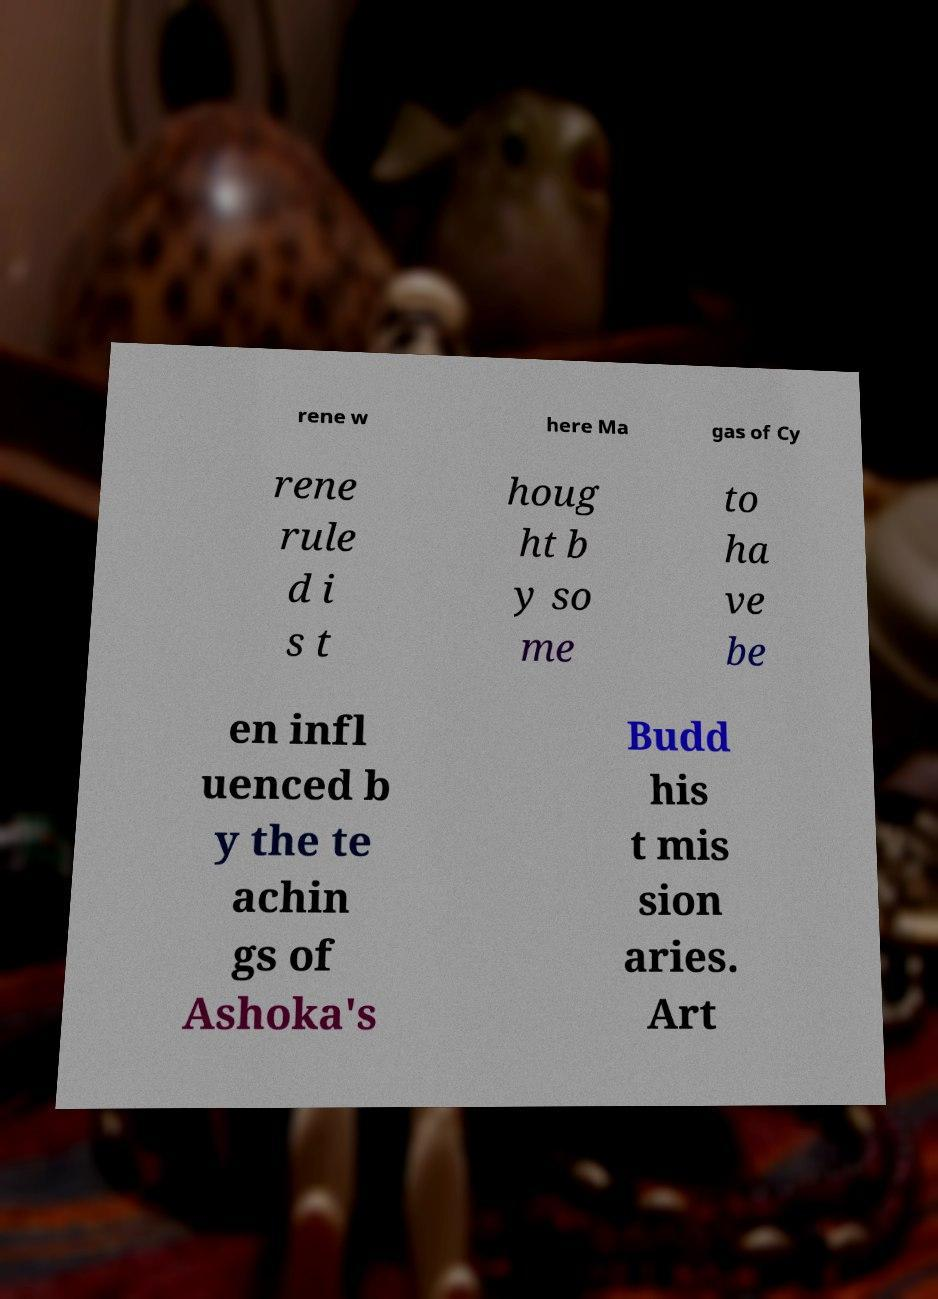For documentation purposes, I need the text within this image transcribed. Could you provide that? rene w here Ma gas of Cy rene rule d i s t houg ht b y so me to ha ve be en infl uenced b y the te achin gs of Ashoka's Budd his t mis sion aries. Art 